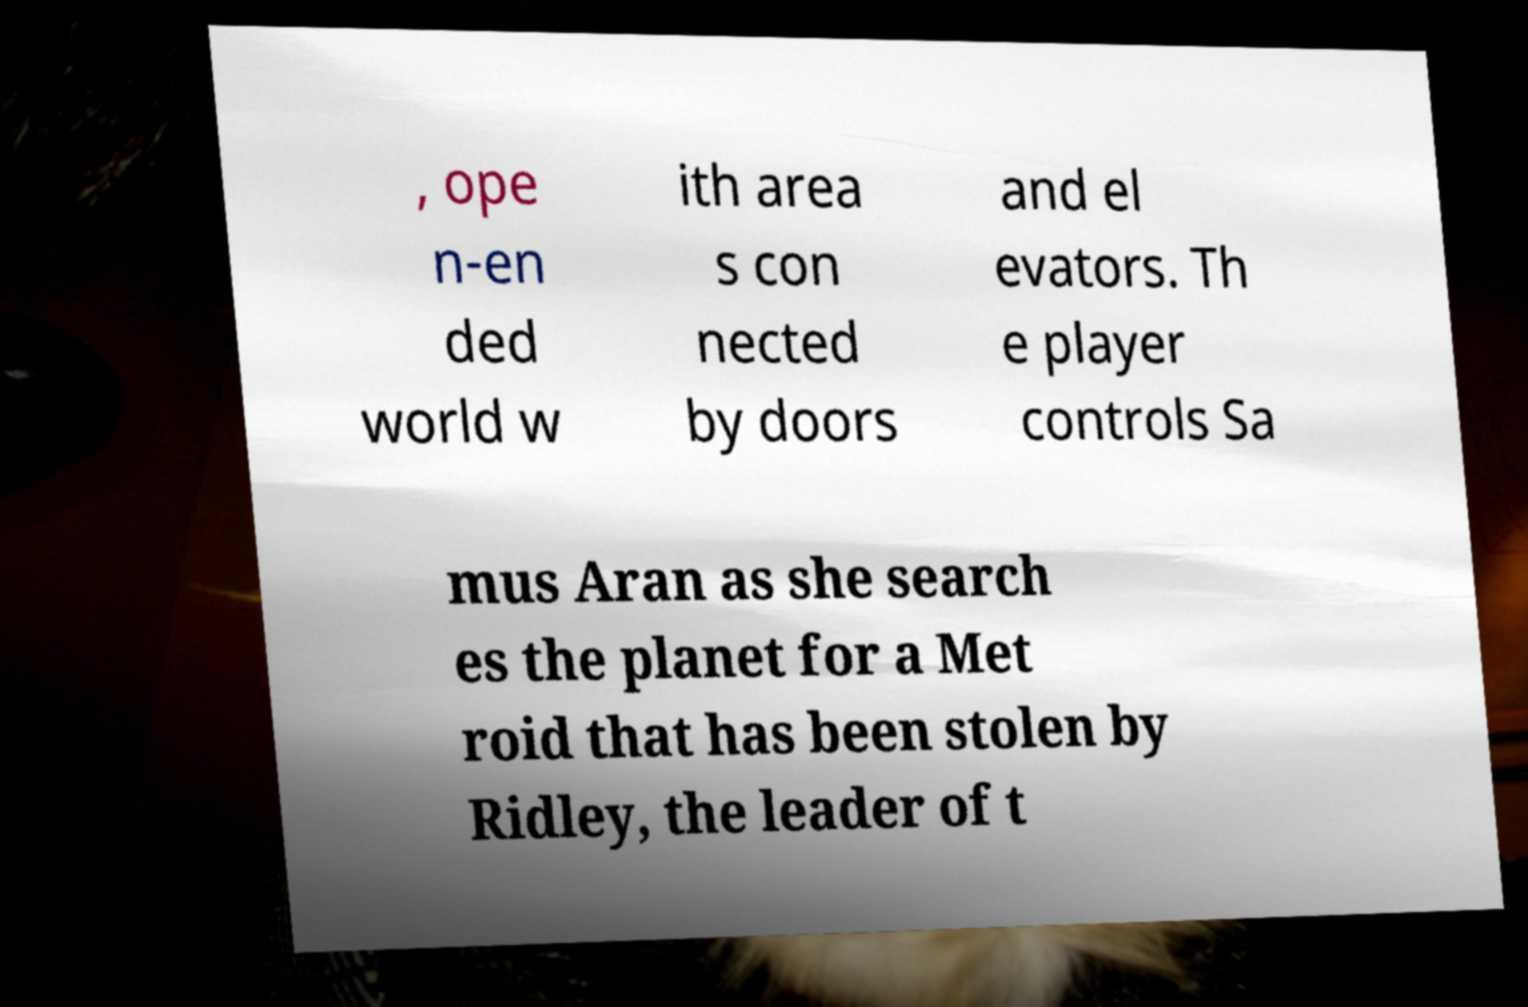Could you extract and type out the text from this image? , ope n-en ded world w ith area s con nected by doors and el evators. Th e player controls Sa mus Aran as she search es the planet for a Met roid that has been stolen by Ridley, the leader of t 